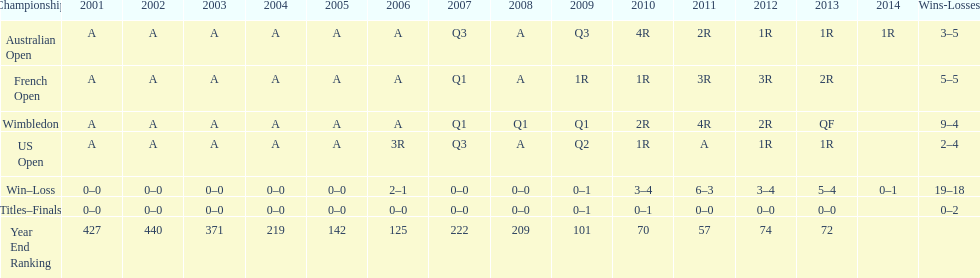In what year was the best year end ranking achieved? 2011. 